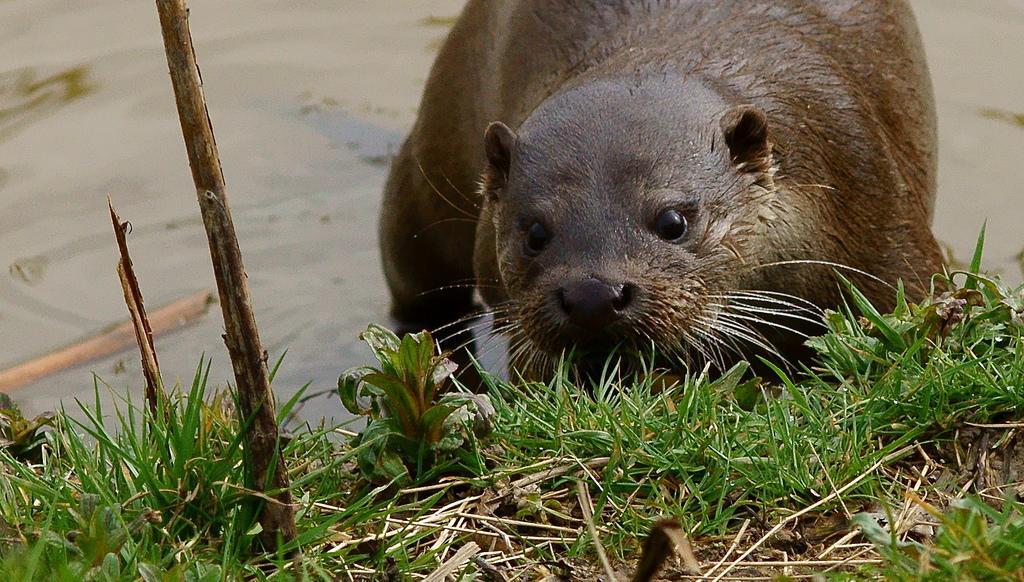Please provide a concise description of this image. In this image I can see an animal in the water, stick and grass. This image is taken may be near the lake. 